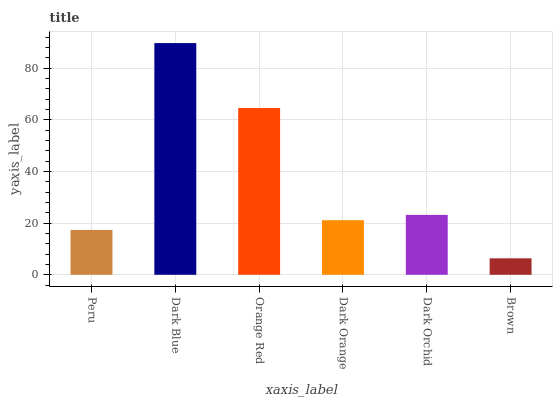Is Brown the minimum?
Answer yes or no. Yes. Is Dark Blue the maximum?
Answer yes or no. Yes. Is Orange Red the minimum?
Answer yes or no. No. Is Orange Red the maximum?
Answer yes or no. No. Is Dark Blue greater than Orange Red?
Answer yes or no. Yes. Is Orange Red less than Dark Blue?
Answer yes or no. Yes. Is Orange Red greater than Dark Blue?
Answer yes or no. No. Is Dark Blue less than Orange Red?
Answer yes or no. No. Is Dark Orchid the high median?
Answer yes or no. Yes. Is Dark Orange the low median?
Answer yes or no. Yes. Is Peru the high median?
Answer yes or no. No. Is Brown the low median?
Answer yes or no. No. 